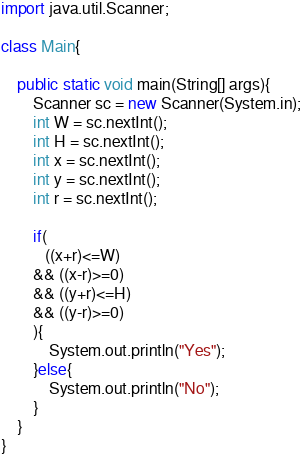<code> <loc_0><loc_0><loc_500><loc_500><_Java_>import java.util.Scanner;

class Main{

	public static void main(String[] args){
		Scanner sc = new Scanner(System.in);
		int W = sc.nextInt();
		int H = sc.nextInt();
		int x = sc.nextInt();
		int y = sc.nextInt();
		int r = sc.nextInt();
		
		if(
		   ((x+r)<=W)
		&& ((x-r)>=0)
		&& ((y+r)<=H) 
		&& ((y-r)>=0)
		){
			System.out.println("Yes");
		}else{
			System.out.println("No");
		}
	}
}
</code> 